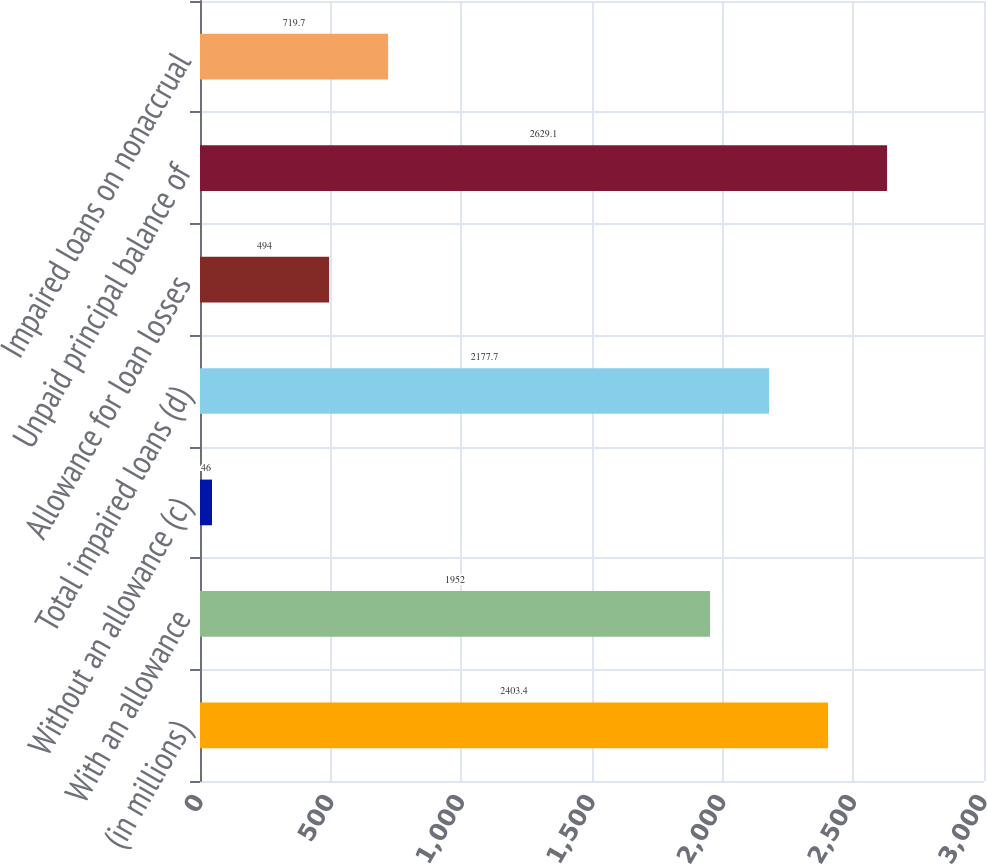Convert chart to OTSL. <chart><loc_0><loc_0><loc_500><loc_500><bar_chart><fcel>(in millions)<fcel>With an allowance<fcel>Without an allowance (c)<fcel>Total impaired loans (d)<fcel>Allowance for loan losses<fcel>Unpaid principal balance of<fcel>Impaired loans on nonaccrual<nl><fcel>2403.4<fcel>1952<fcel>46<fcel>2177.7<fcel>494<fcel>2629.1<fcel>719.7<nl></chart> 